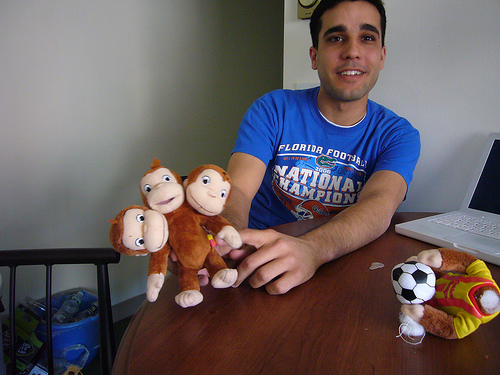<image>
Can you confirm if the toy is on the table? No. The toy is not positioned on the table. They may be near each other, but the toy is not supported by or resting on top of the table. Where is the shirt in relation to the man? Is it to the left of the man? No. The shirt is not to the left of the man. From this viewpoint, they have a different horizontal relationship. 